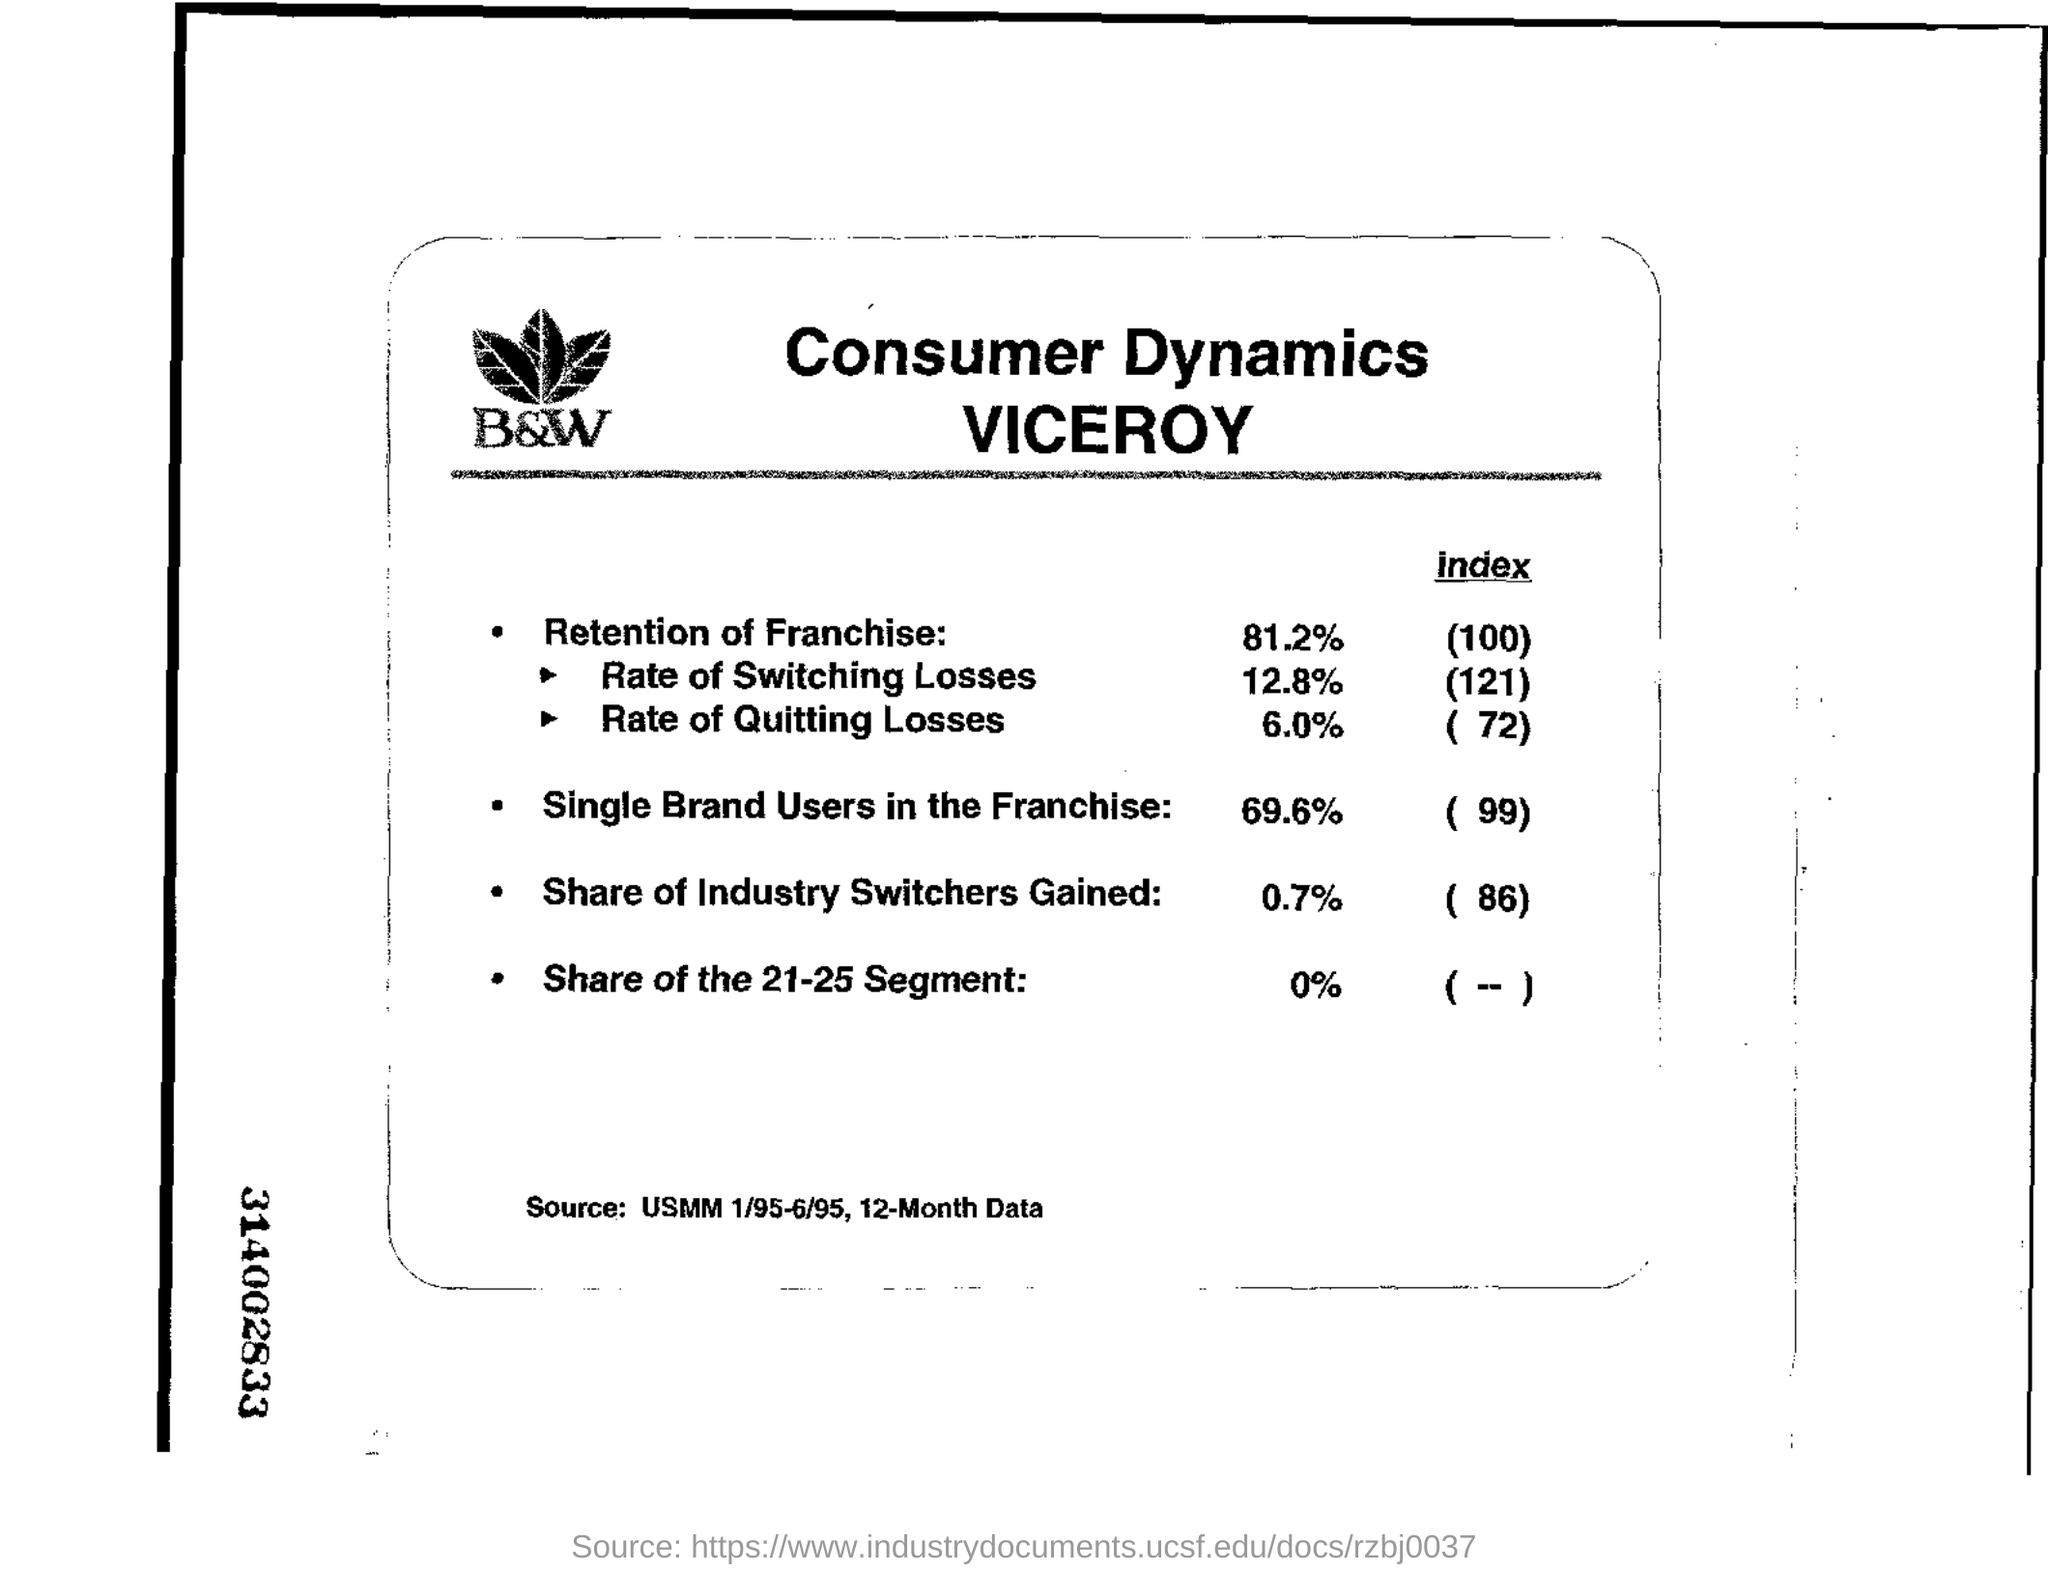What is the name of the company?
Ensure brevity in your answer.  B&W. What is the share of the 21-25 segment mentioned?
Ensure brevity in your answer.  0%. What is the index value for Retention of Franchise ?
Your answer should be compact. 100. 